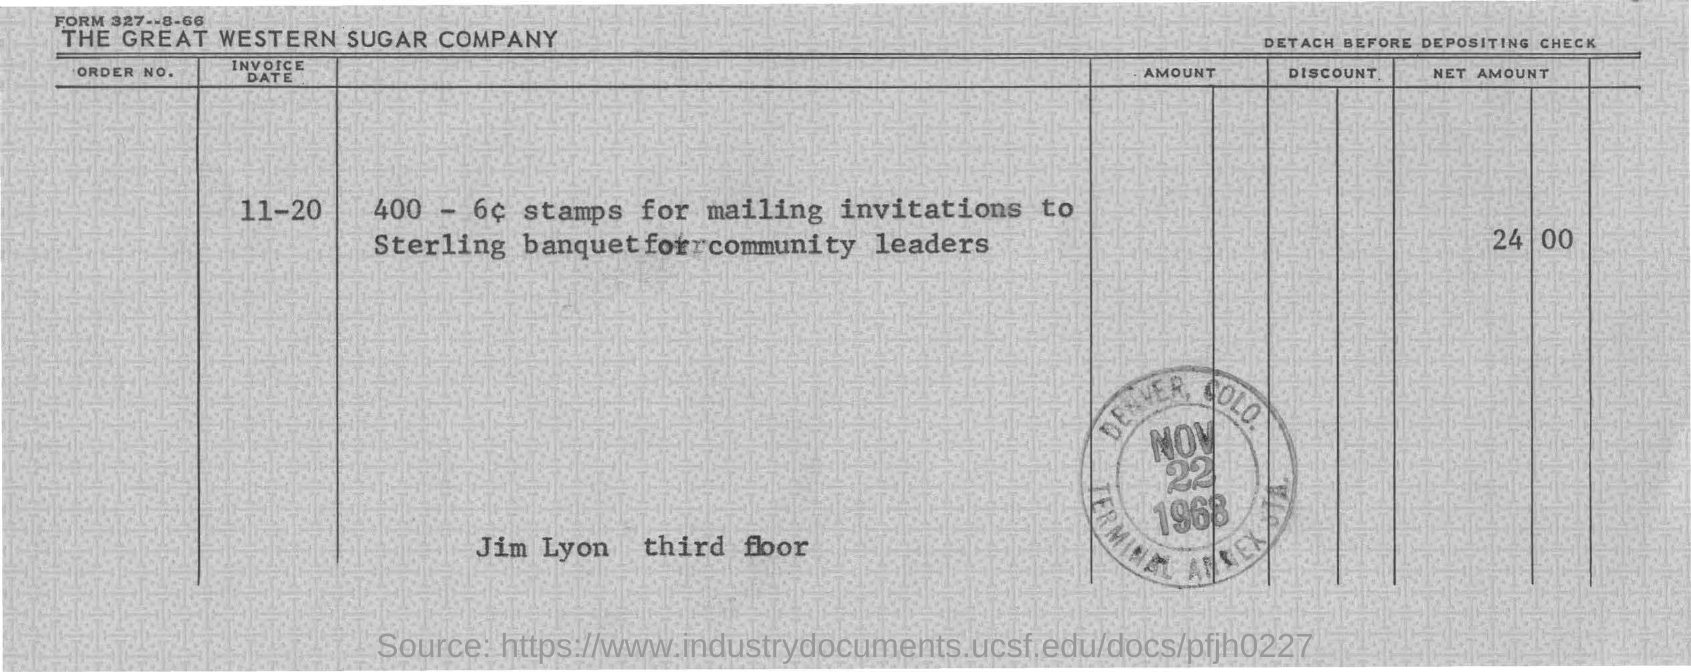What is the net amount?
Offer a very short reply. 24 00. What is the Invoice date?
Provide a short and direct response. 11-20. 